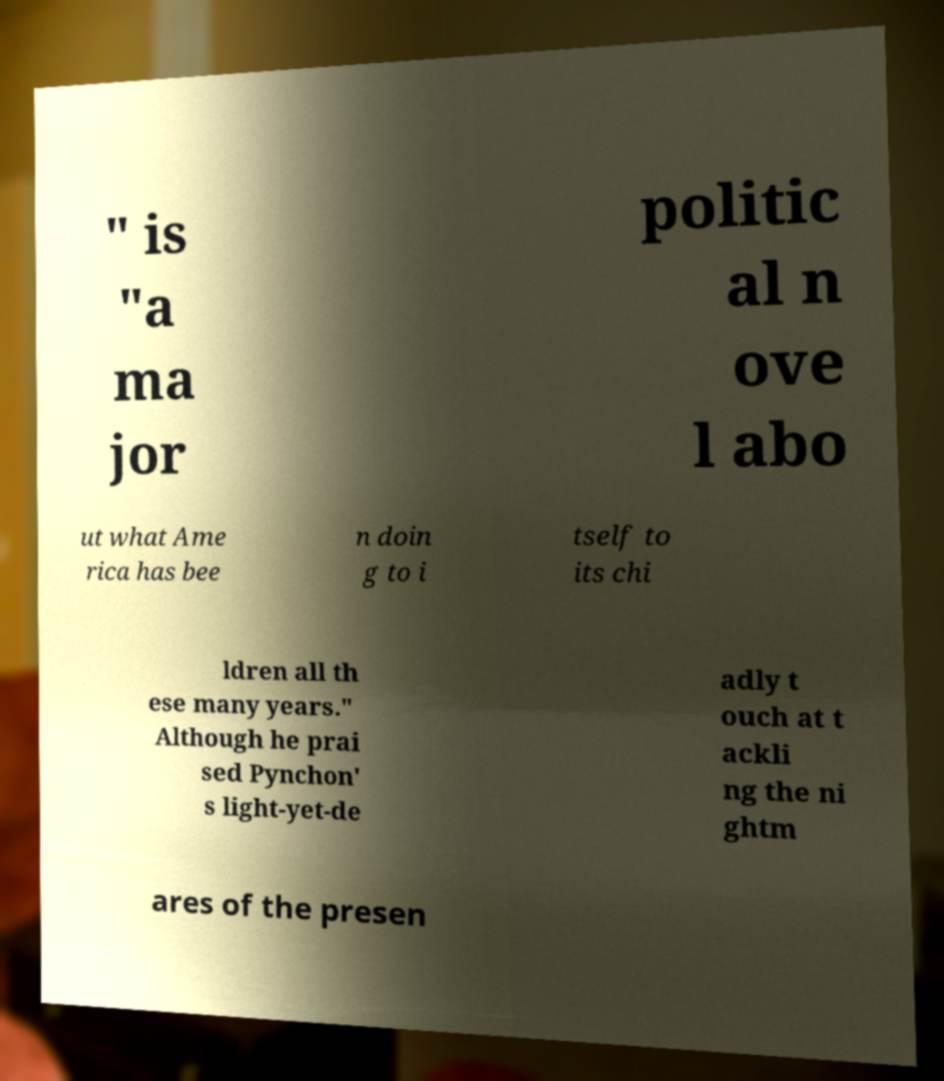For documentation purposes, I need the text within this image transcribed. Could you provide that? " is "a ma jor politic al n ove l abo ut what Ame rica has bee n doin g to i tself to its chi ldren all th ese many years." Although he prai sed Pynchon' s light-yet-de adly t ouch at t ackli ng the ni ghtm ares of the presen 